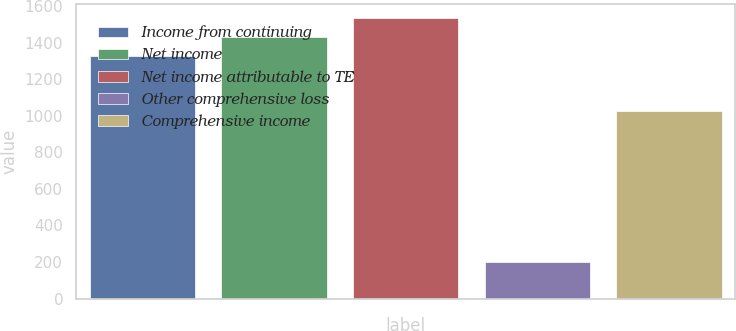Convert chart to OTSL. <chart><loc_0><loc_0><loc_500><loc_500><bar_chart><fcel>Income from continuing<fcel>Net income<fcel>Net income attributable to TE<fcel>Other comprehensive loss<fcel>Comprehensive income<nl><fcel>1328.7<fcel>1431.4<fcel>1534.1<fcel>199<fcel>1027<nl></chart> 